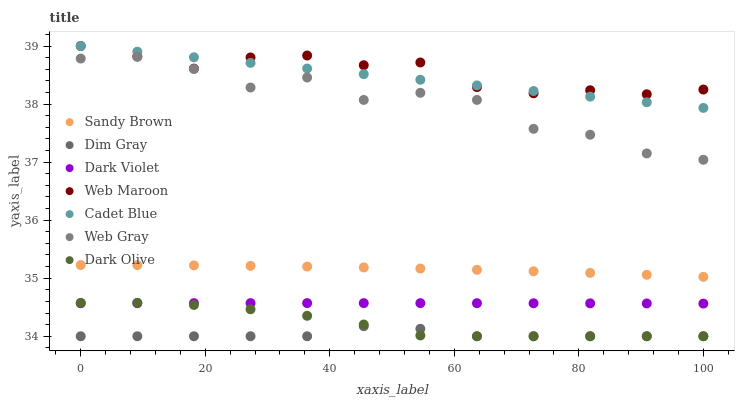Does Dim Gray have the minimum area under the curve?
Answer yes or no. Yes. Does Web Maroon have the maximum area under the curve?
Answer yes or no. Yes. Does Dark Olive have the minimum area under the curve?
Answer yes or no. No. Does Dark Olive have the maximum area under the curve?
Answer yes or no. No. Is Cadet Blue the smoothest?
Answer yes or no. Yes. Is Web Gray the roughest?
Answer yes or no. Yes. Is Dark Olive the smoothest?
Answer yes or no. No. Is Dark Olive the roughest?
Answer yes or no. No. Does Dark Olive have the lowest value?
Answer yes or no. Yes. Does Web Maroon have the lowest value?
Answer yes or no. No. Does Web Maroon have the highest value?
Answer yes or no. Yes. Does Dark Olive have the highest value?
Answer yes or no. No. Is Sandy Brown less than Web Gray?
Answer yes or no. Yes. Is Web Maroon greater than Dark Olive?
Answer yes or no. Yes. Does Dim Gray intersect Dark Olive?
Answer yes or no. Yes. Is Dim Gray less than Dark Olive?
Answer yes or no. No. Is Dim Gray greater than Dark Olive?
Answer yes or no. No. Does Sandy Brown intersect Web Gray?
Answer yes or no. No. 